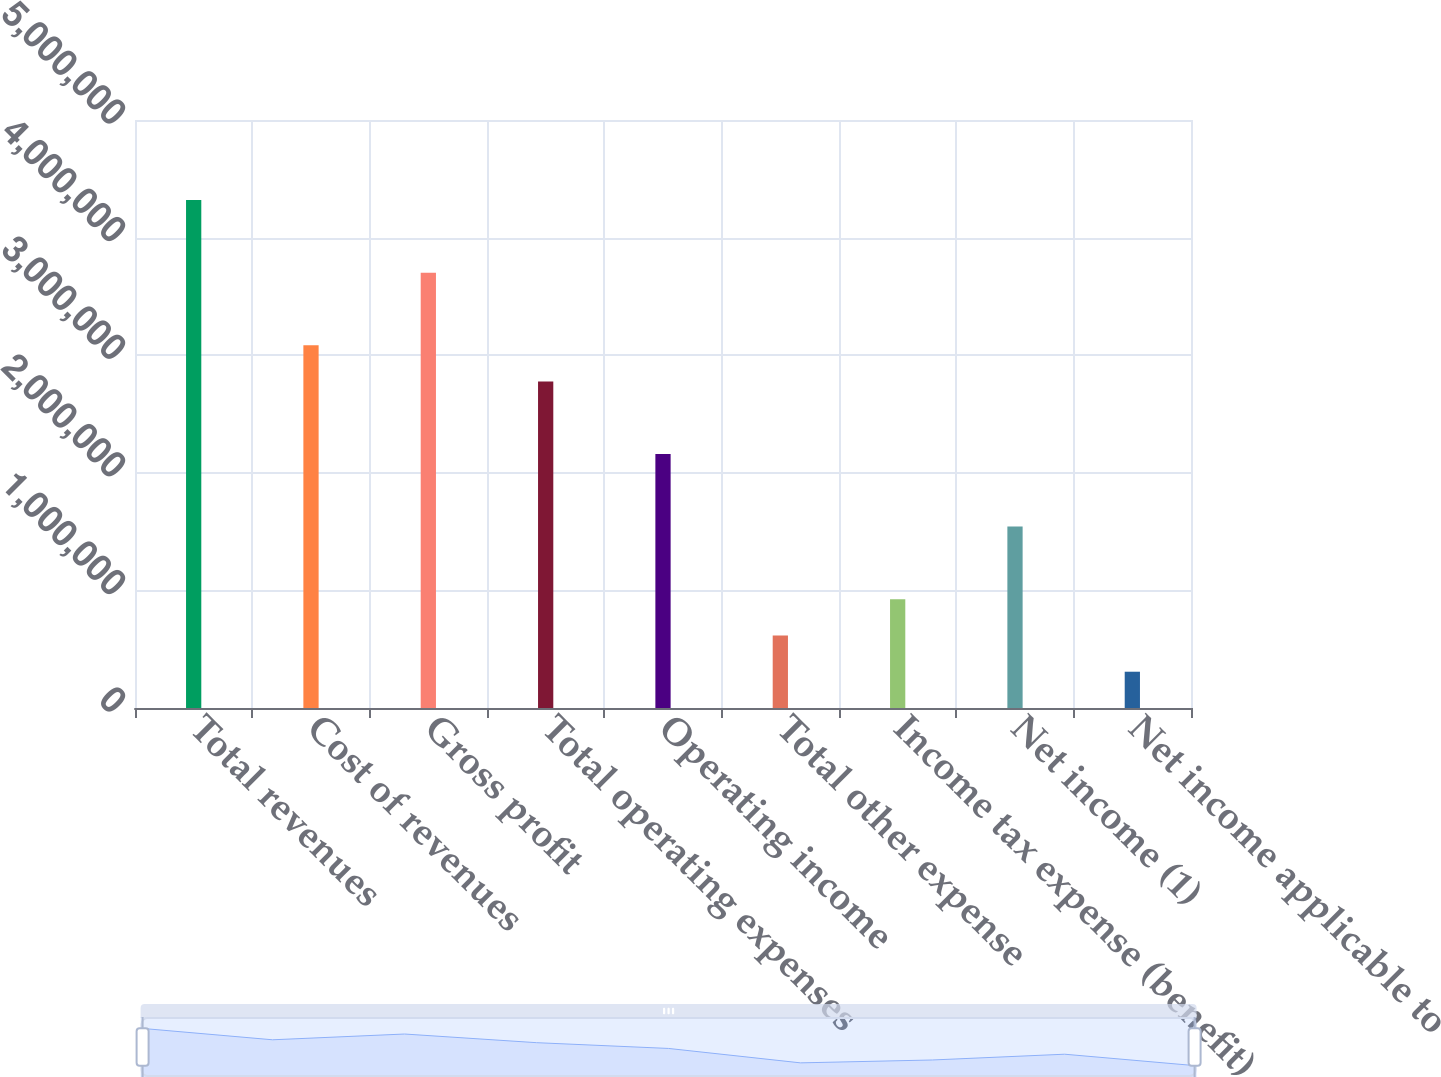Convert chart to OTSL. <chart><loc_0><loc_0><loc_500><loc_500><bar_chart><fcel>Total revenues<fcel>Cost of revenues<fcel>Gross profit<fcel>Total operating expenses<fcel>Operating income<fcel>Total other expense<fcel>Income tax expense (benefit)<fcel>Net income (1)<fcel>Net income applicable to<nl><fcel>4.31886e+06<fcel>3.08491e+06<fcel>3.70188e+06<fcel>2.77642e+06<fcel>2.15944e+06<fcel>616989<fcel>925479<fcel>1.54246e+06<fcel>308500<nl></chart> 